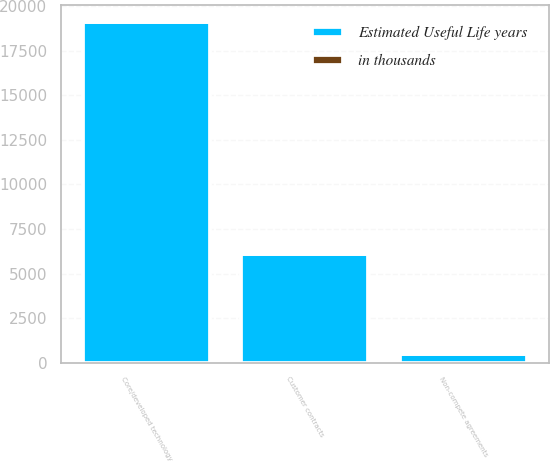<chart> <loc_0><loc_0><loc_500><loc_500><stacked_bar_chart><ecel><fcel>Core/developed technology<fcel>Customer contracts<fcel>Non-compete agreements<nl><fcel>Estimated Useful Life years<fcel>19100<fcel>6100<fcel>500<nl><fcel>in thousands<fcel>25<fcel>5<fcel>3<nl></chart> 